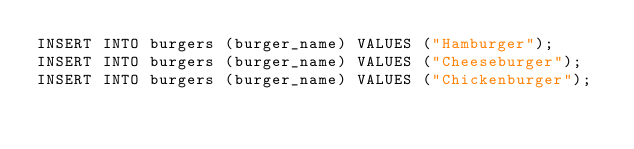<code> <loc_0><loc_0><loc_500><loc_500><_SQL_>INSERT INTO burgers (burger_name) VALUES ("Hamburger");
INSERT INTO burgers (burger_name) VALUES ("Cheeseburger");
INSERT INTO burgers (burger_name) VALUES ("Chickenburger");
</code> 